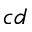Convert formula to latex. <formula><loc_0><loc_0><loc_500><loc_500>c d</formula> 